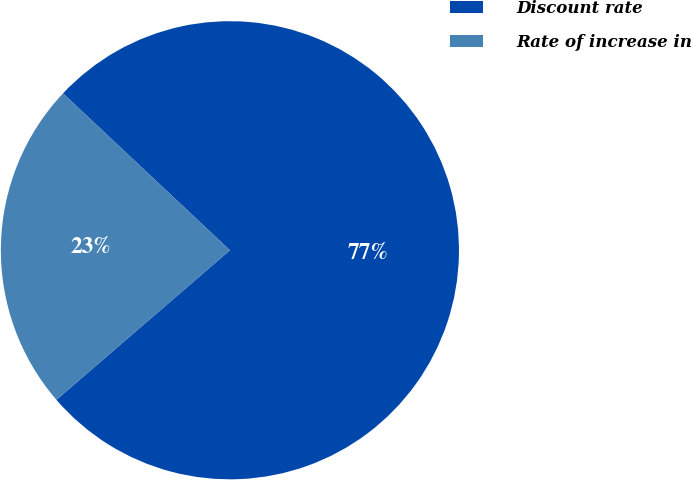Convert chart to OTSL. <chart><loc_0><loc_0><loc_500><loc_500><pie_chart><fcel>Discount rate<fcel>Rate of increase in<nl><fcel>76.67%<fcel>23.33%<nl></chart> 